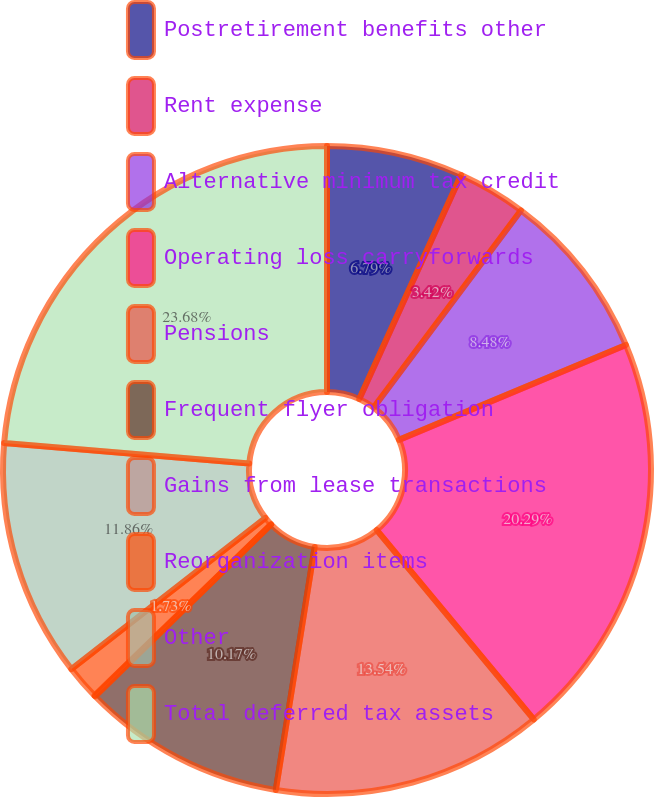<chart> <loc_0><loc_0><loc_500><loc_500><pie_chart><fcel>Postretirement benefits other<fcel>Rent expense<fcel>Alternative minimum tax credit<fcel>Operating loss carryforwards<fcel>Pensions<fcel>Frequent flyer obligation<fcel>Gains from lease transactions<fcel>Reorganization items<fcel>Other<fcel>Total deferred tax assets<nl><fcel>6.79%<fcel>3.42%<fcel>8.48%<fcel>20.29%<fcel>13.54%<fcel>10.17%<fcel>0.04%<fcel>1.73%<fcel>11.86%<fcel>23.67%<nl></chart> 